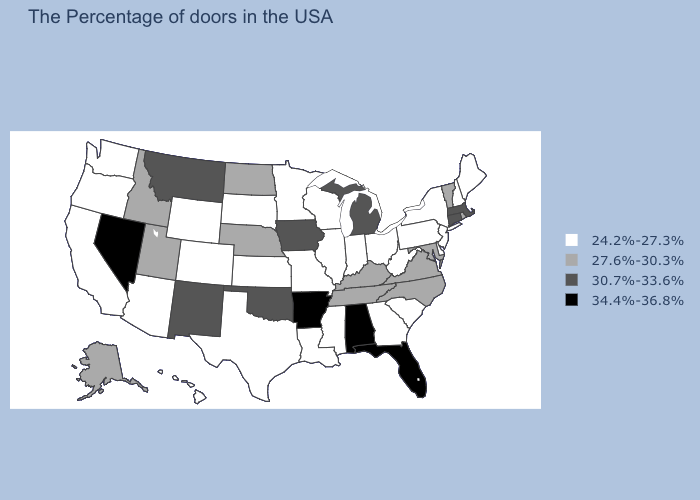Among the states that border Minnesota , which have the lowest value?
Write a very short answer. Wisconsin, South Dakota. Does New Mexico have a lower value than Nevada?
Keep it brief. Yes. Is the legend a continuous bar?
Give a very brief answer. No. Does Mississippi have a lower value than Oregon?
Be succinct. No. How many symbols are there in the legend?
Answer briefly. 4. What is the value of North Carolina?
Be succinct. 27.6%-30.3%. What is the value of Montana?
Short answer required. 30.7%-33.6%. Is the legend a continuous bar?
Give a very brief answer. No. What is the value of Arkansas?
Answer briefly. 34.4%-36.8%. Among the states that border Wisconsin , does Minnesota have the lowest value?
Concise answer only. Yes. Does Connecticut have the highest value in the USA?
Concise answer only. No. Name the states that have a value in the range 34.4%-36.8%?
Short answer required. Florida, Alabama, Arkansas, Nevada. Name the states that have a value in the range 27.6%-30.3%?
Short answer required. Rhode Island, Vermont, Maryland, Virginia, North Carolina, Kentucky, Tennessee, Nebraska, North Dakota, Utah, Idaho, Alaska. Which states hav the highest value in the MidWest?
Short answer required. Michigan, Iowa. What is the value of Michigan?
Keep it brief. 30.7%-33.6%. 